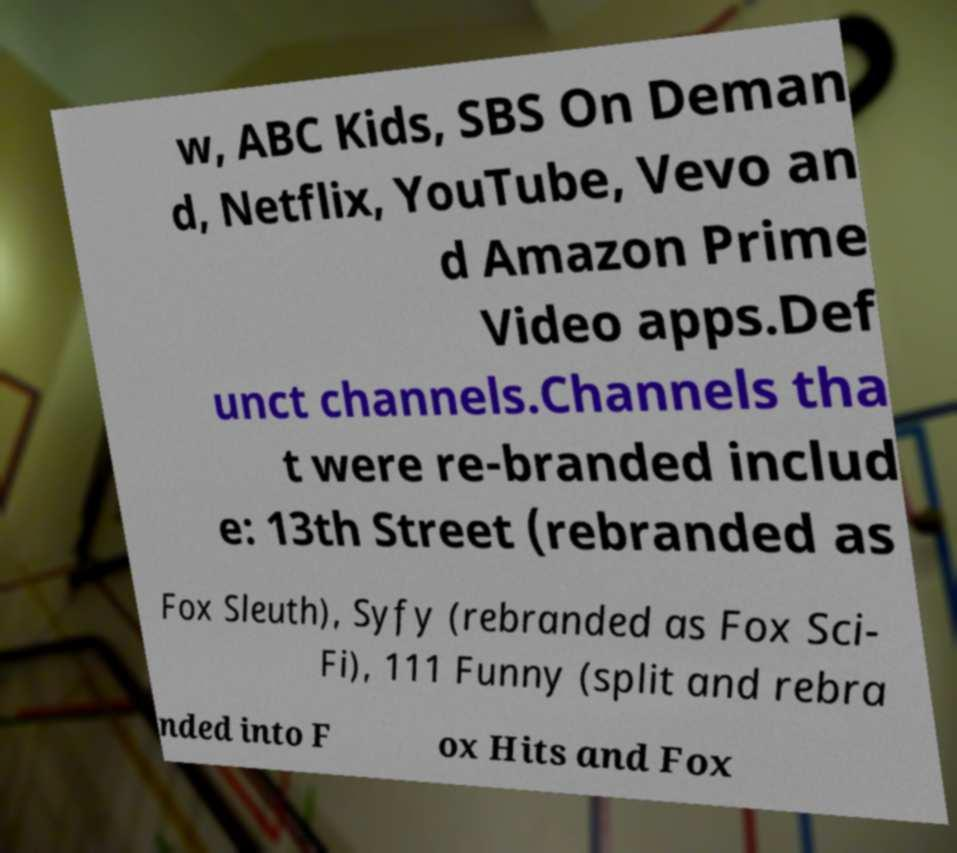What messages or text are displayed in this image? I need them in a readable, typed format. w, ABC Kids, SBS On Deman d, Netflix, YouTube, Vevo an d Amazon Prime Video apps.Def unct channels.Channels tha t were re-branded includ e: 13th Street (rebranded as Fox Sleuth), Syfy (rebranded as Fox Sci- Fi), 111 Funny (split and rebra nded into F ox Hits and Fox 